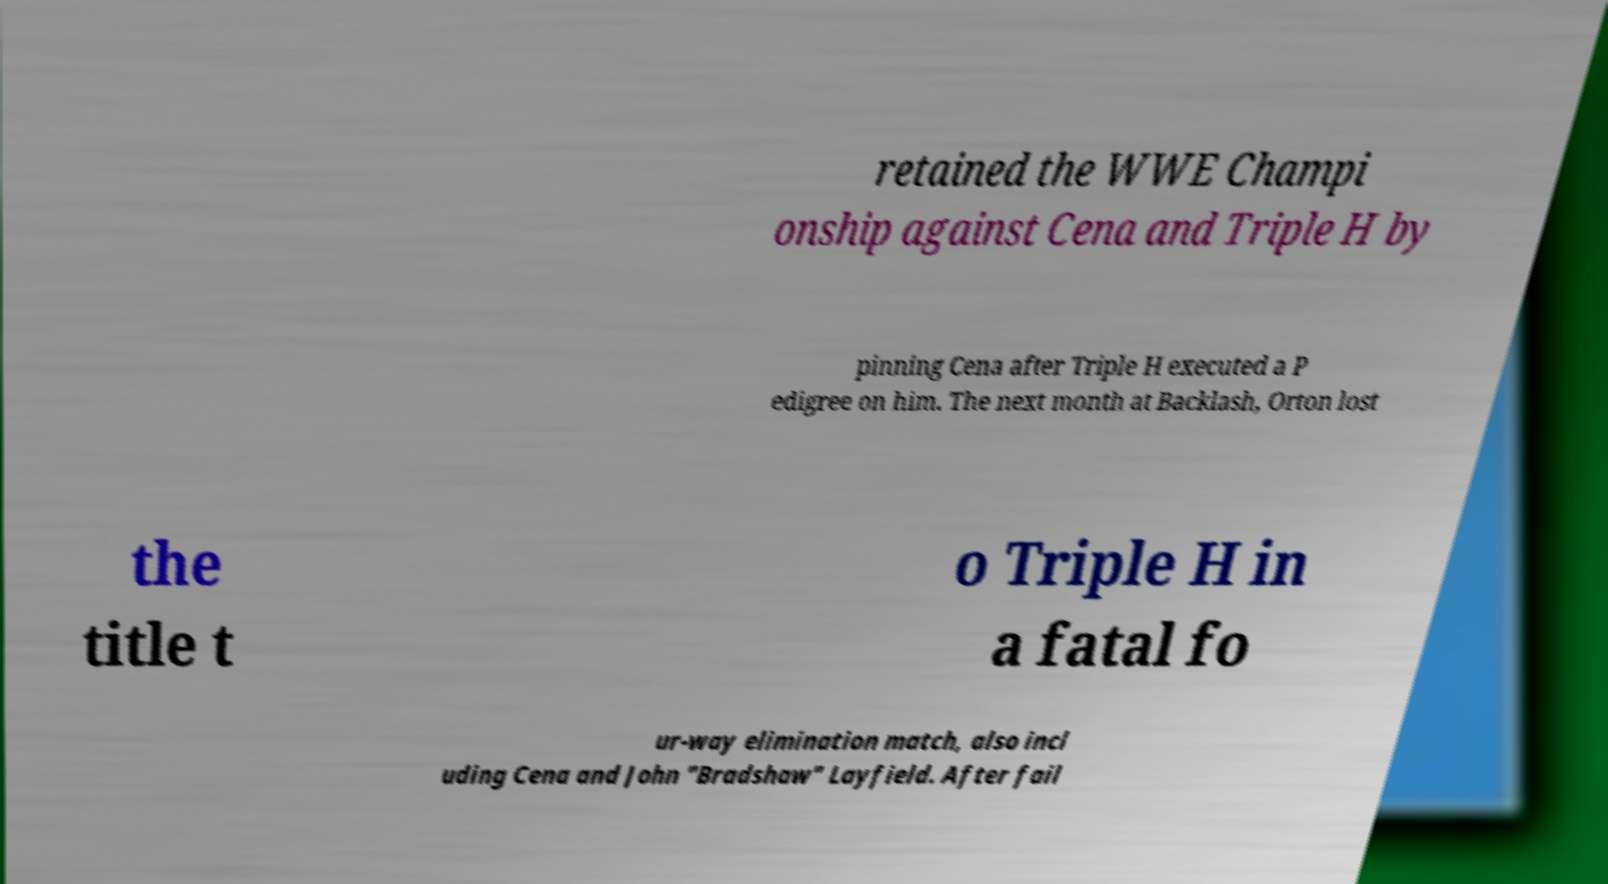Could you assist in decoding the text presented in this image and type it out clearly? retained the WWE Champi onship against Cena and Triple H by pinning Cena after Triple H executed a P edigree on him. The next month at Backlash, Orton lost the title t o Triple H in a fatal fo ur-way elimination match, also incl uding Cena and John "Bradshaw" Layfield. After fail 